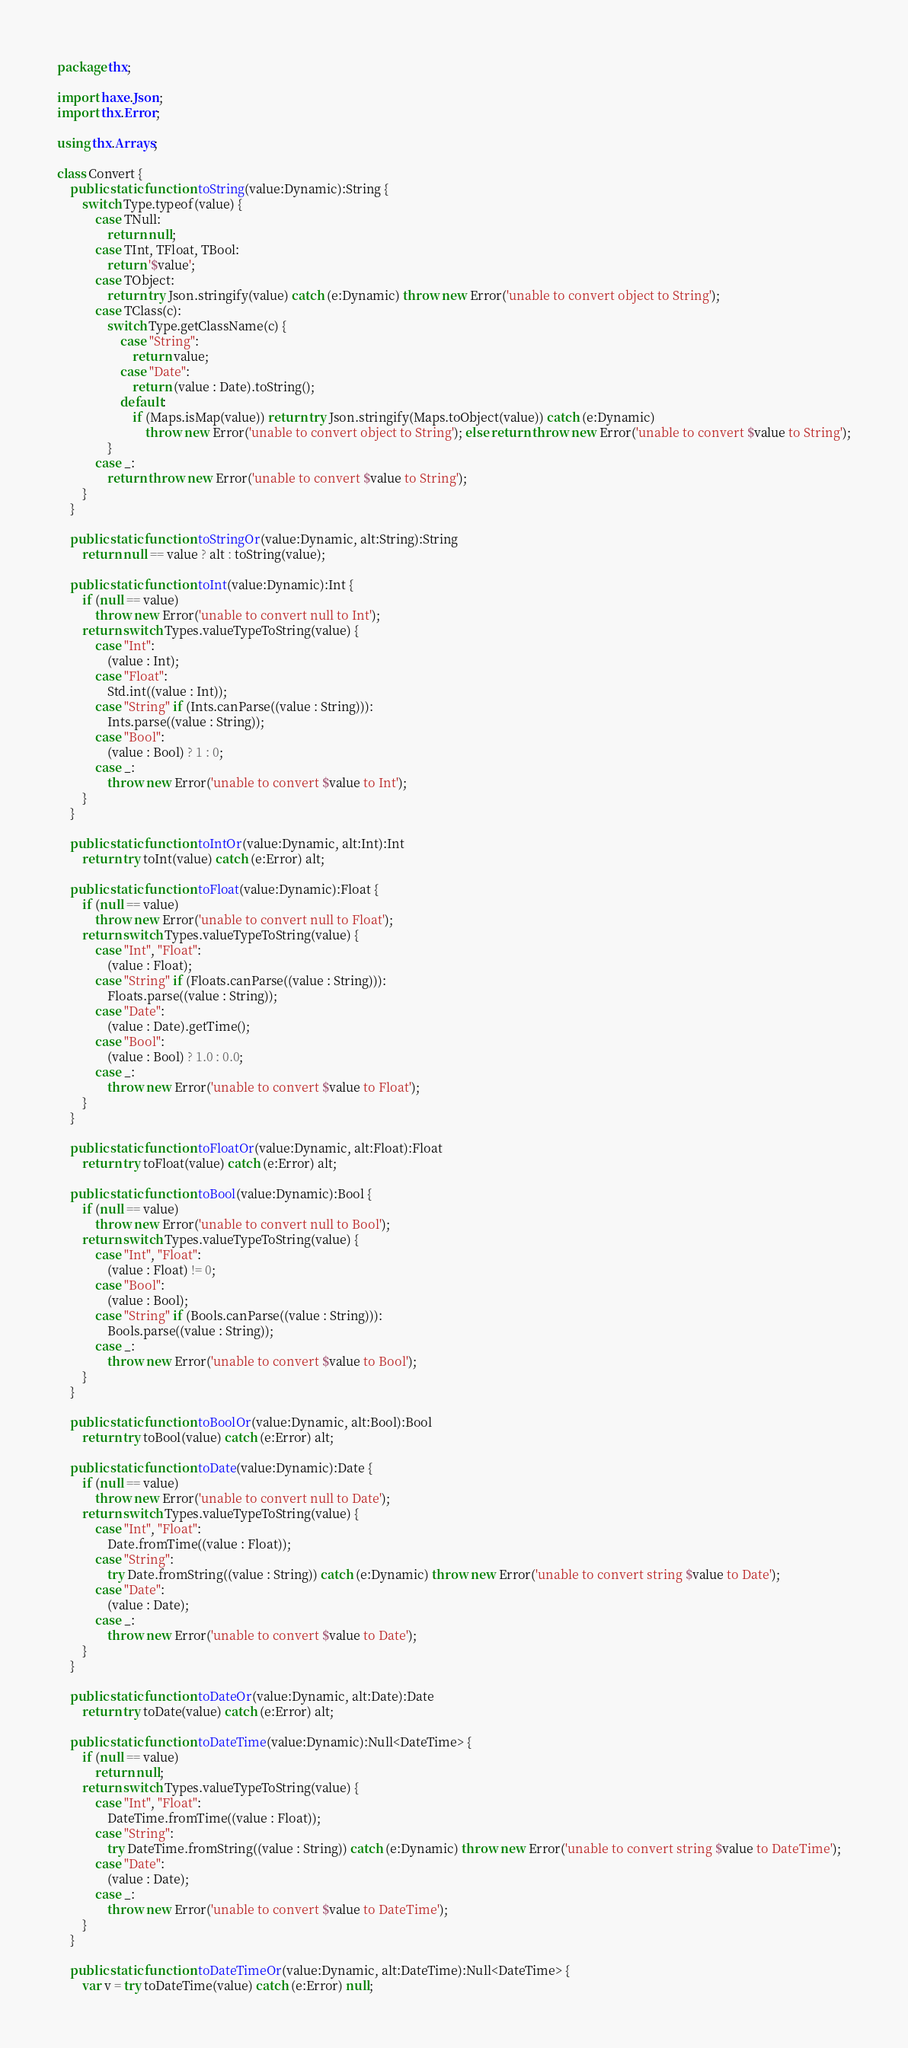Convert code to text. <code><loc_0><loc_0><loc_500><loc_500><_Haxe_>package thx;

import haxe.Json;
import thx.Error;

using thx.Arrays;

class Convert {
	public static function toString(value:Dynamic):String {
		switch Type.typeof(value) {
			case TNull:
				return null;
			case TInt, TFloat, TBool:
				return '$value';
			case TObject:
				return try Json.stringify(value) catch (e:Dynamic) throw new Error('unable to convert object to String');
			case TClass(c):
				switch Type.getClassName(c) {
					case "String":
						return value;
					case "Date":
						return (value : Date).toString();
					default:
						if (Maps.isMap(value)) return try Json.stringify(Maps.toObject(value)) catch (e:Dynamic)
							throw new Error('unable to convert object to String'); else return throw new Error('unable to convert $value to String');
				}
			case _:
				return throw new Error('unable to convert $value to String');
		}
	}

	public static function toStringOr(value:Dynamic, alt:String):String
		return null == value ? alt : toString(value);

	public static function toInt(value:Dynamic):Int {
		if (null == value)
			throw new Error('unable to convert null to Int');
		return switch Types.valueTypeToString(value) {
			case "Int":
				(value : Int);
			case "Float":
				Std.int((value : Int));
			case "String" if (Ints.canParse((value : String))):
				Ints.parse((value : String));
			case "Bool":
				(value : Bool) ? 1 : 0;
			case _:
				throw new Error('unable to convert $value to Int');
		}
	}

	public static function toIntOr(value:Dynamic, alt:Int):Int
		return try toInt(value) catch (e:Error) alt;

	public static function toFloat(value:Dynamic):Float {
		if (null == value)
			throw new Error('unable to convert null to Float');
		return switch Types.valueTypeToString(value) {
			case "Int", "Float":
				(value : Float);
			case "String" if (Floats.canParse((value : String))):
				Floats.parse((value : String));
			case "Date":
				(value : Date).getTime();
			case "Bool":
				(value : Bool) ? 1.0 : 0.0;
			case _:
				throw new Error('unable to convert $value to Float');
		}
	}

	public static function toFloatOr(value:Dynamic, alt:Float):Float
		return try toFloat(value) catch (e:Error) alt;

	public static function toBool(value:Dynamic):Bool {
		if (null == value)
			throw new Error('unable to convert null to Bool');
		return switch Types.valueTypeToString(value) {
			case "Int", "Float":
				(value : Float) != 0;
			case "Bool":
				(value : Bool);
			case "String" if (Bools.canParse((value : String))):
				Bools.parse((value : String));
			case _:
				throw new Error('unable to convert $value to Bool');
		}
	}

	public static function toBoolOr(value:Dynamic, alt:Bool):Bool
		return try toBool(value) catch (e:Error) alt;

	public static function toDate(value:Dynamic):Date {
		if (null == value)
			throw new Error('unable to convert null to Date');
		return switch Types.valueTypeToString(value) {
			case "Int", "Float":
				Date.fromTime((value : Float));
			case "String":
				try Date.fromString((value : String)) catch (e:Dynamic) throw new Error('unable to convert string $value to Date');
			case "Date":
				(value : Date);
			case _:
				throw new Error('unable to convert $value to Date');
		}
	}

	public static function toDateOr(value:Dynamic, alt:Date):Date
		return try toDate(value) catch (e:Error) alt;

	public static function toDateTime(value:Dynamic):Null<DateTime> {
		if (null == value)
			return null;
		return switch Types.valueTypeToString(value) {
			case "Int", "Float":
				DateTime.fromTime((value : Float));
			case "String":
				try DateTime.fromString((value : String)) catch (e:Dynamic) throw new Error('unable to convert string $value to DateTime');
			case "Date":
				(value : Date);
			case _:
				throw new Error('unable to convert $value to DateTime');
		}
	}

	public static function toDateTimeOr(value:Dynamic, alt:DateTime):Null<DateTime> {
		var v = try toDateTime(value) catch (e:Error) null;</code> 